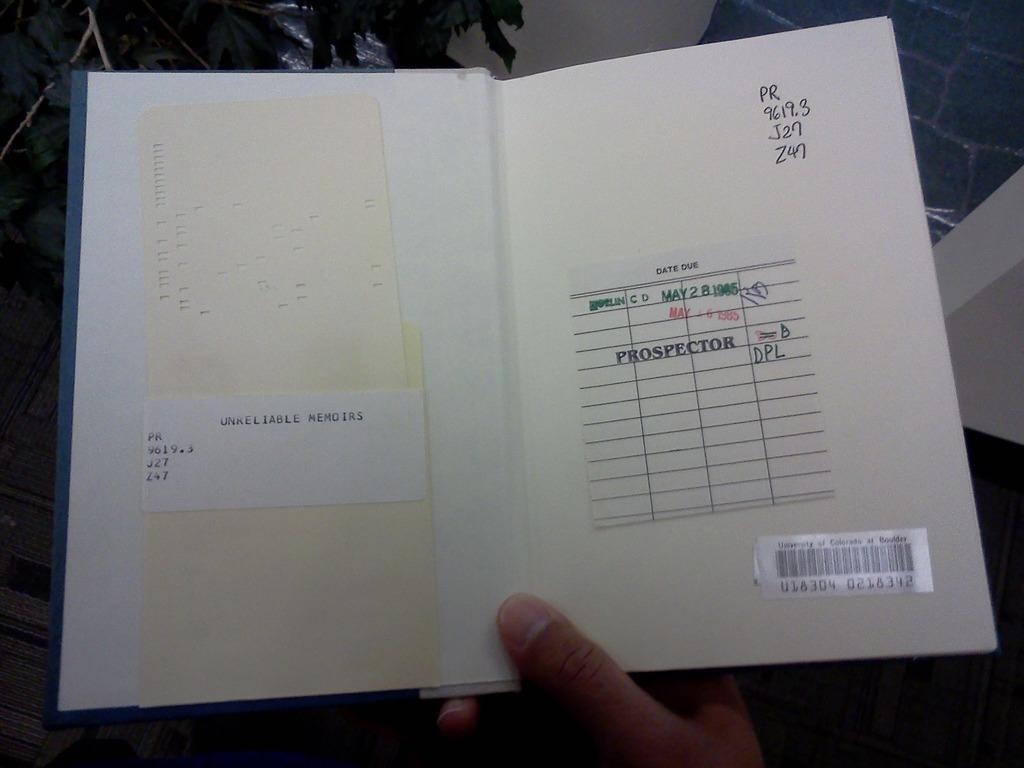<image>
Give a short and clear explanation of the subsequent image. A person is holding a copy of the book Unreliable Memoir. 